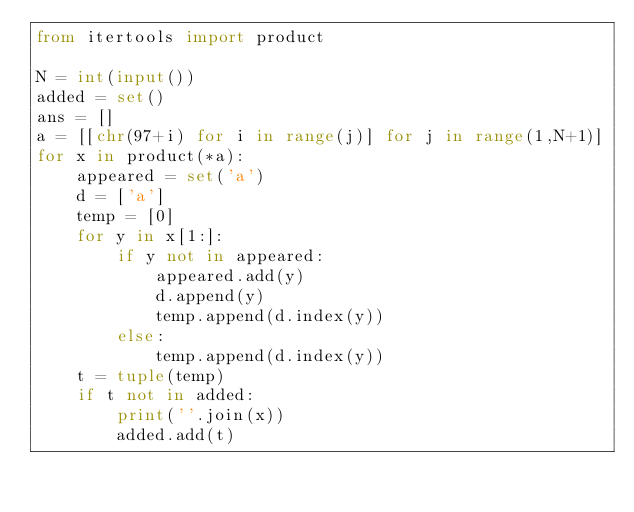<code> <loc_0><loc_0><loc_500><loc_500><_Python_>from itertools import product

N = int(input())
added = set()
ans = []
a = [[chr(97+i) for i in range(j)] for j in range(1,N+1)]
for x in product(*a):
    appeared = set('a')
    d = ['a']
    temp = [0]
    for y in x[1:]:
        if y not in appeared:
            appeared.add(y)
            d.append(y)
            temp.append(d.index(y))
        else:
            temp.append(d.index(y))
    t = tuple(temp)
    if t not in added:
        print(''.join(x))
        added.add(t)</code> 